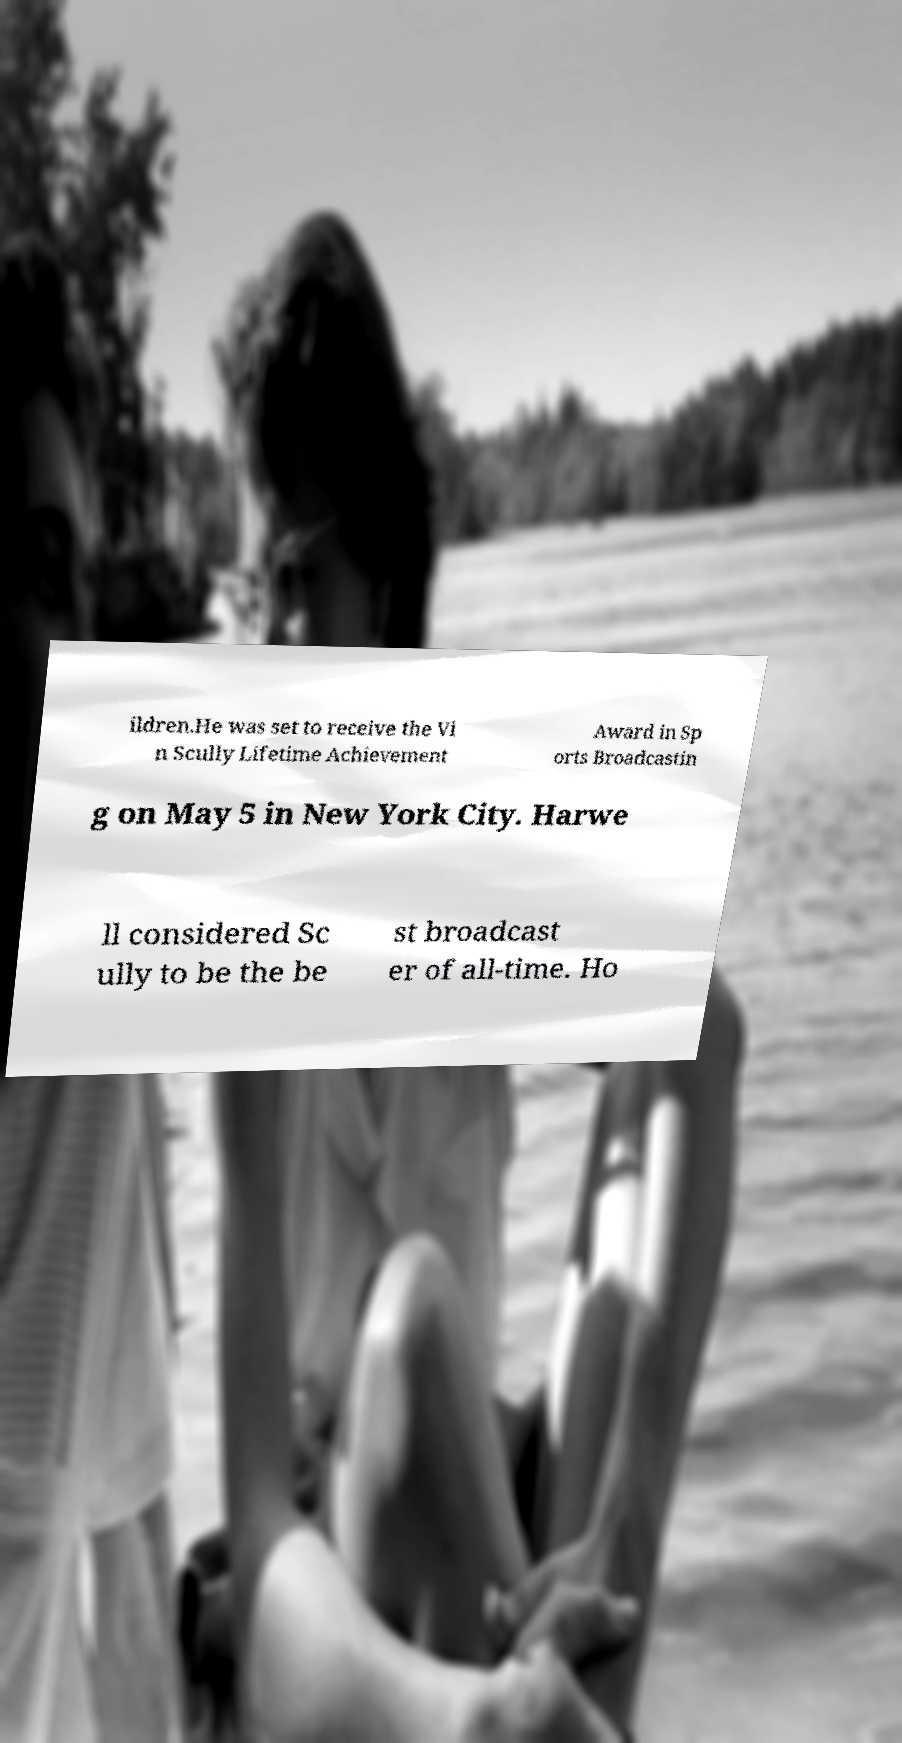For documentation purposes, I need the text within this image transcribed. Could you provide that? ildren.He was set to receive the Vi n Scully Lifetime Achievement Award in Sp orts Broadcastin g on May 5 in New York City. Harwe ll considered Sc ully to be the be st broadcast er of all-time. Ho 